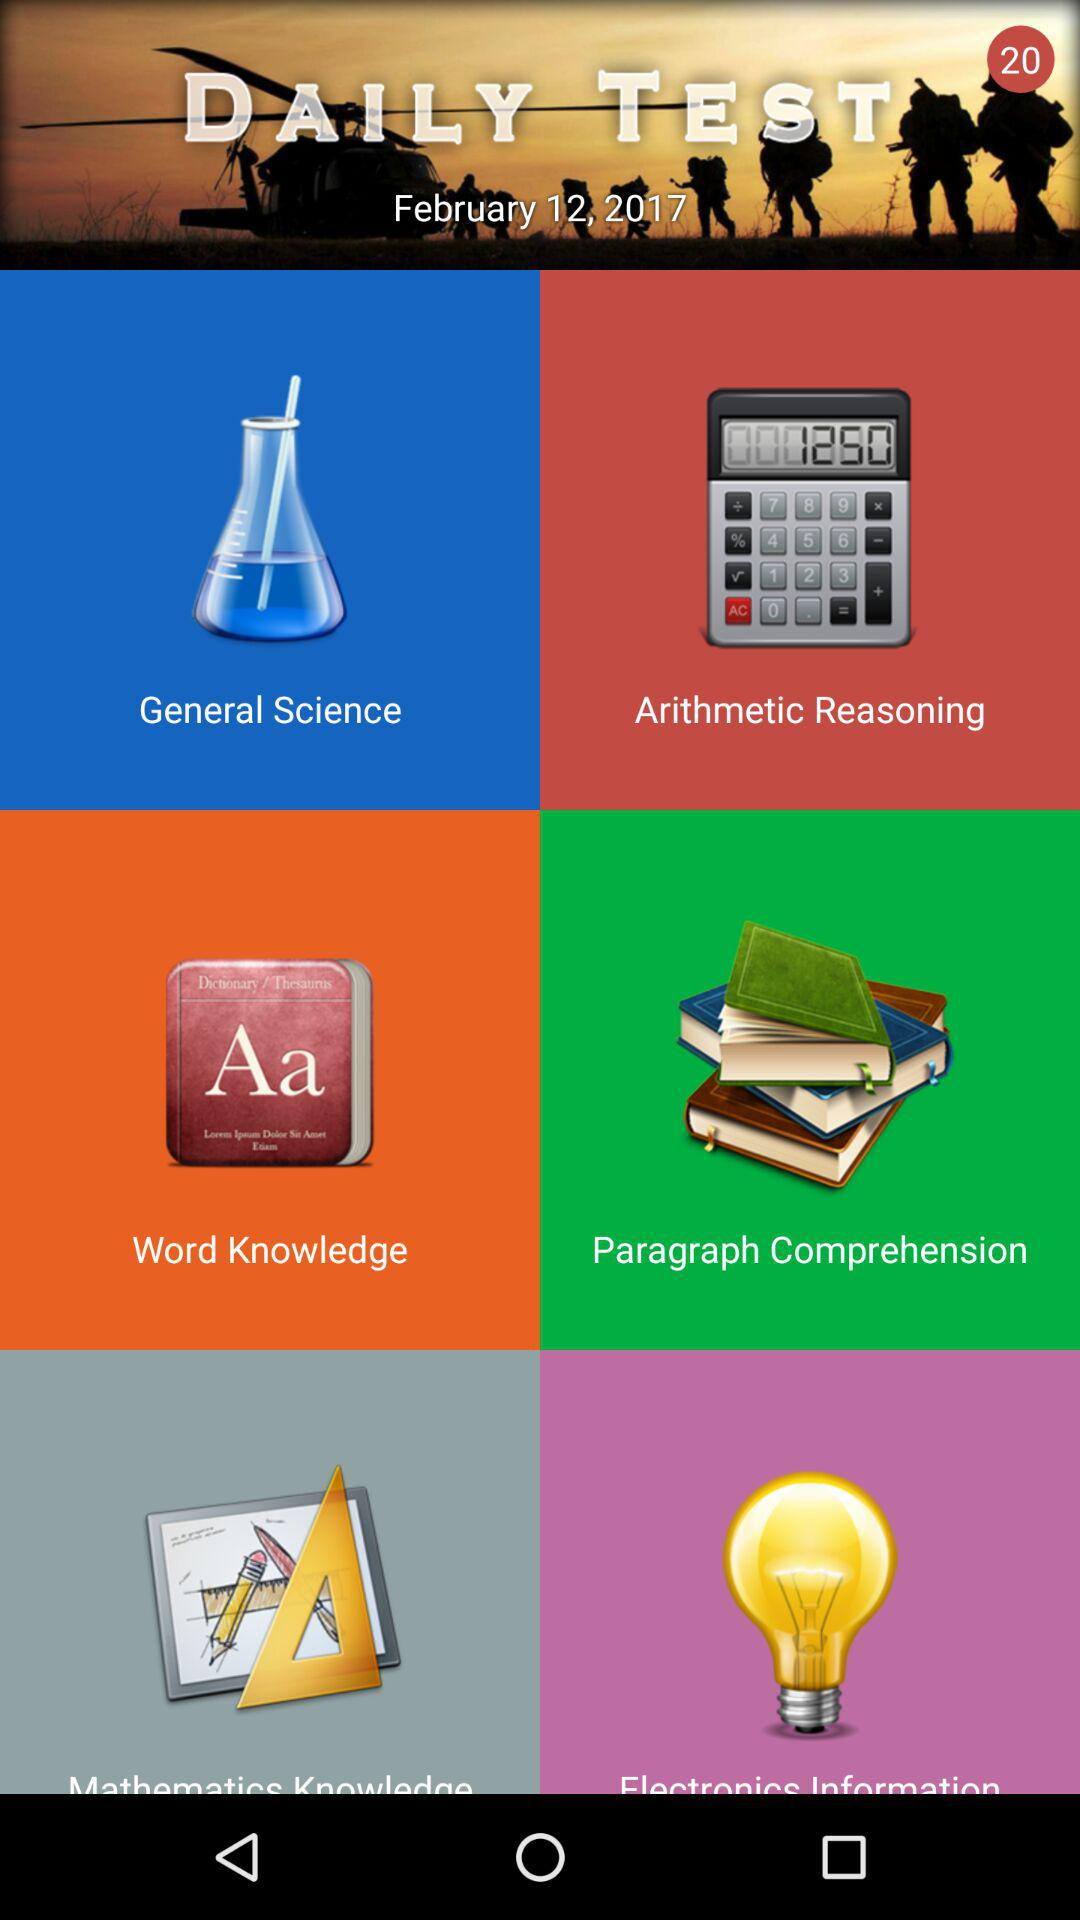What date is mentioned? The mentioned date is February 12, 2017. 